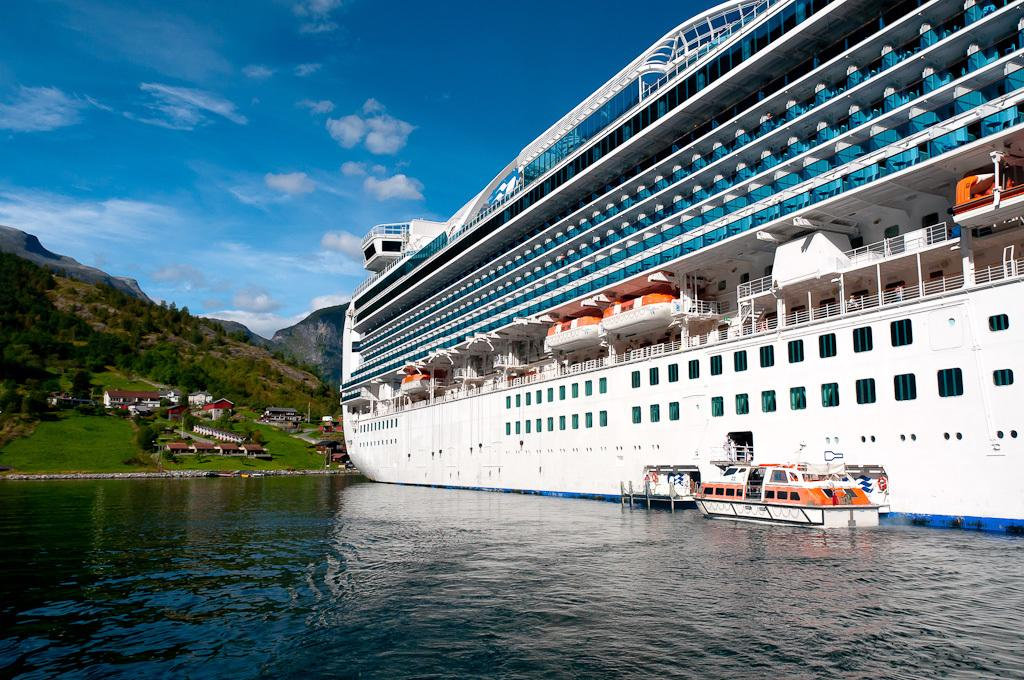What type of watercraft can be seen in the image? There is a ship and a boat in the image. Where are the ship and boat located? Both the ship and boat are on the water in the image. What other structures are visible in the image? There are houses and trees in the image. What natural features can be seen in the background? There are mountains visible in the image. What part of the natural environment is visible in the image? The sky is visible in the image. How many dimes are scattered on the ground in the image? There are no dimes visible in the image. What type of grape is being used as a decoration on the ship in the image? There are no grapes present in the image, and the ship is not decorated with any grapes. 